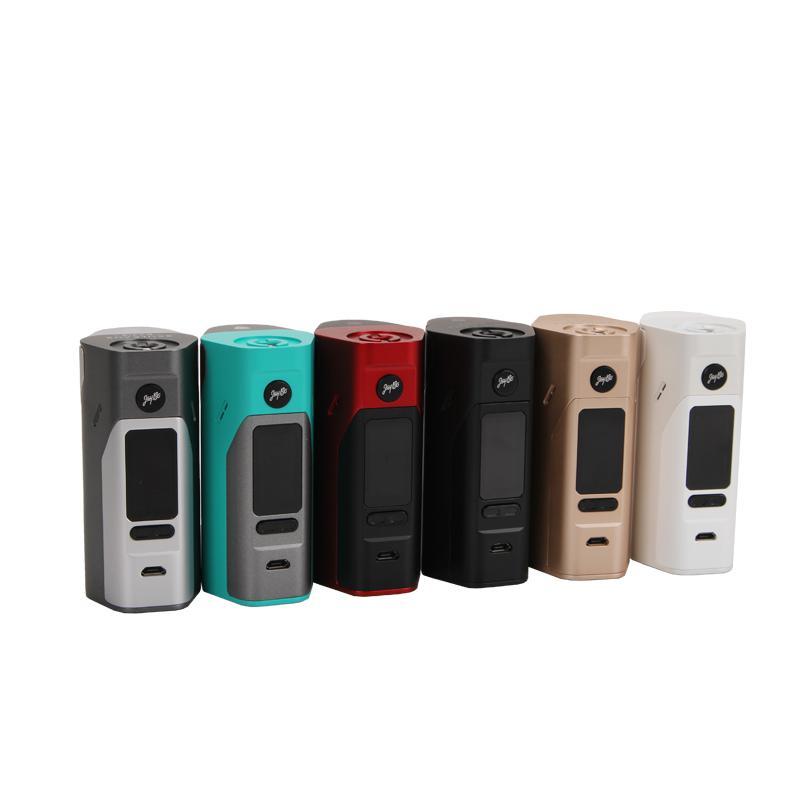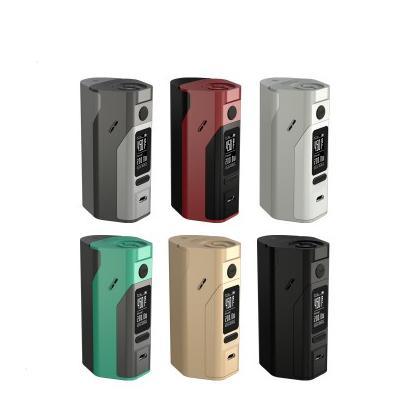The first image is the image on the left, the second image is the image on the right. Evaluate the accuracy of this statement regarding the images: "The same number of phones, each sporting a distinct color design, is in each image.". Is it true? Answer yes or no. Yes. The first image is the image on the left, the second image is the image on the right. For the images displayed, is the sentence "The right image contains exactly four vape devices." factually correct? Answer yes or no. No. 